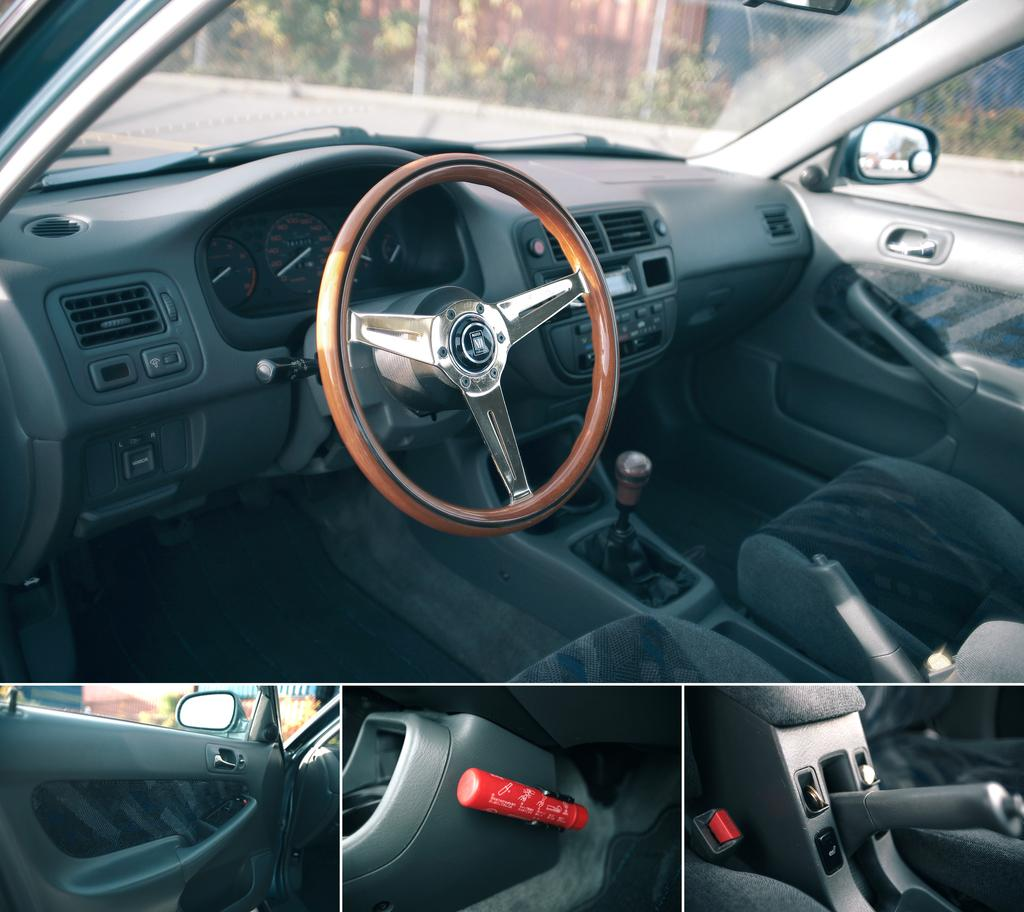What type of vehicle is shown in the image? The image shows an inside view of a car. What material are the windows made of in the car? The windows in the car are made of glass. Can you describe any other objects or elements visible in the image? Yes, there are plants visible in the image. What type of crook can be seen stealing the moon in the image? There is no crook or moon present in the image; it shows an inside view of a car with plants visible. 